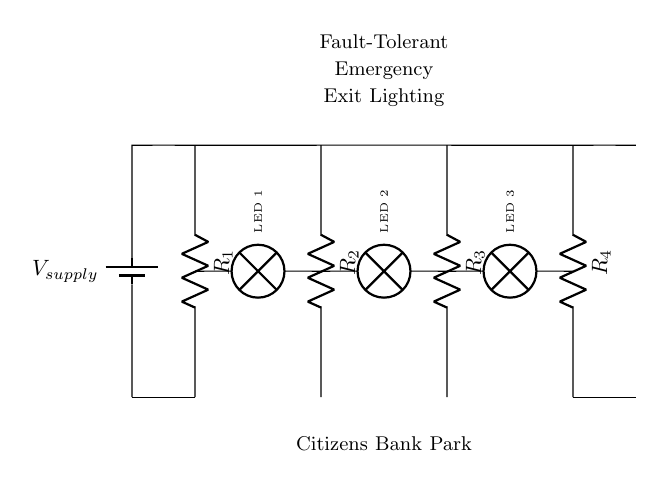What type of circuit is shown? The diagram represents a parallel circuit, as all components are connected across the same two nodes, allowing multiple paths for the current to flow.
Answer: Parallel How many resistors are in the circuit? There are four resistors depicted in the circuit diagram, labeled R1, R2, R3, and R4, each arranged in parallel.
Answer: Four What is the purpose of the lamps in the circuit? The lamps, labeled LED 1, LED 2, and LED 3, serve as indicators that demonstrate when there is power flowing through the circuit, ensuring visibility during an emergency.
Answer: Indicators If one resistor fails, how does that affect the circuit? If one resistor fails, the other resistors will still function because they provide alternative paths for the current; this is a key feature of a fault-tolerant design.
Answer: No effect What does the label on the top of the circuit signify? The label indicates that the circuit is designed for fault-tolerant emergency exit lighting, highlighting its purpose to ensure exits are illuminated during emergencies.
Answer: Fault-Tolerant Emergency Exit Lighting How does the voltage from the supply compare to the voltage across each resistor? In a parallel circuit, the voltage across each resistor is equal to the supply voltage; therefore, each resistor receives the same voltage from the source.
Answer: Equal 